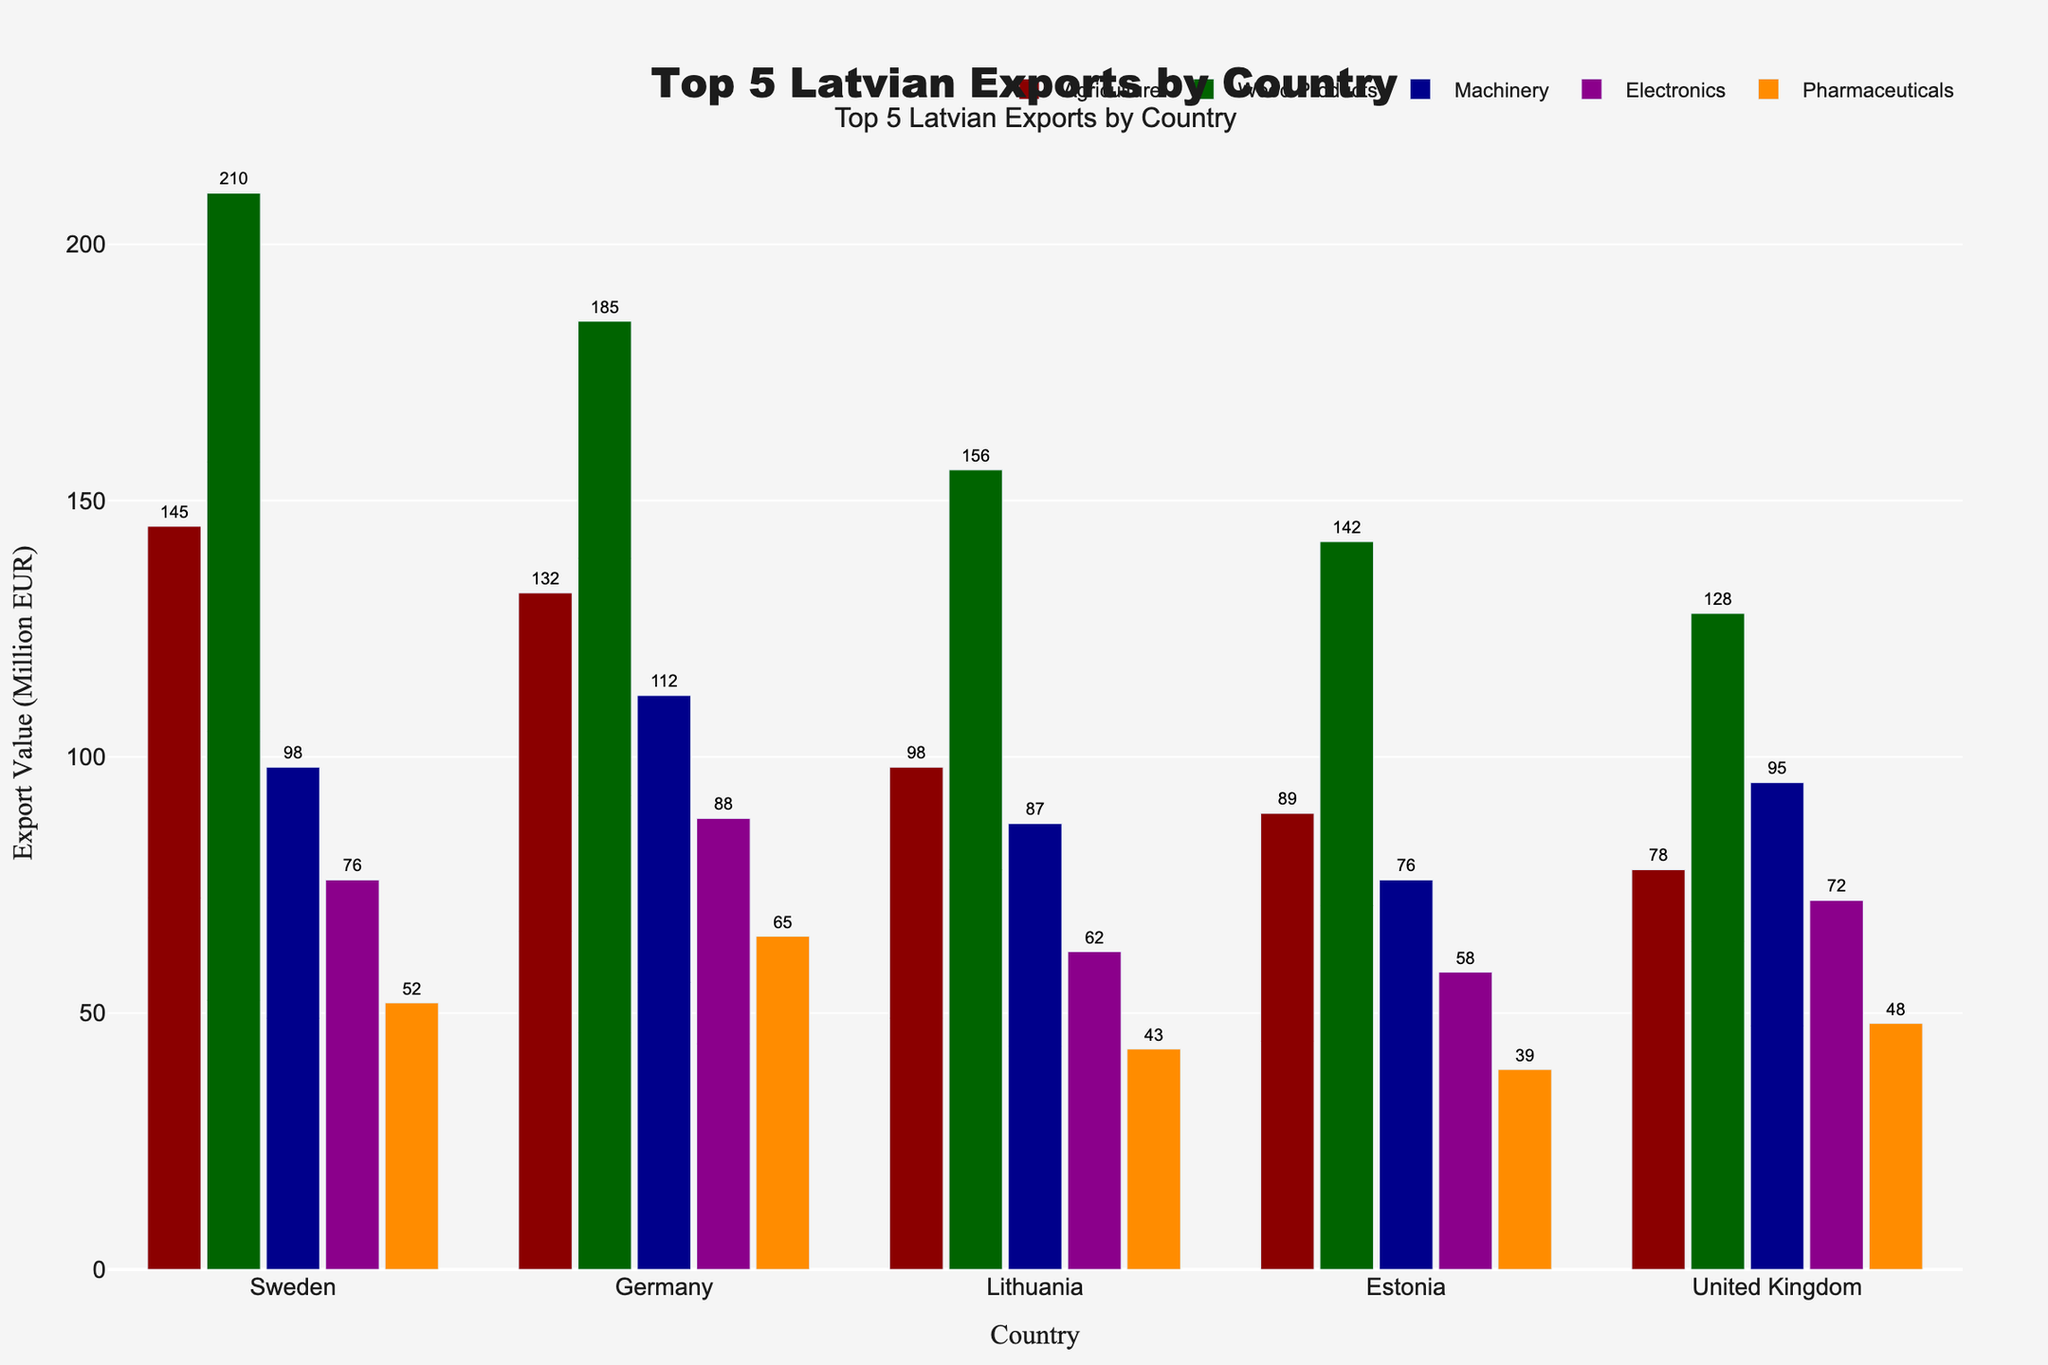What are the top three countries importing Latvian wood products? By examining the heights of the bars for wood products, we see that Sweden, Germany, and Lithuania have the highest values.
Answer: Sweden, Germany, Lithuania Which category accounts for the highest export value to Germany? Compare the bar heights across categories for Germany. The wood products category has the highest bar.
Answer: Wood Products How much more valuable are agriculture exports to Sweden compared to the United Kingdom? Subtract the agriculture export value to the United Kingdom (78) from the value to Sweden (145): 145 - 78.
Answer: 67 Which country receives the most diverse range of export values (widest spread among different categories)? Calculate the range (max - min) for each country and compare them. Germany has the widest range: max (185) - min (65) = 120.
Answer: Germany What is the total export value for electronics across all five countries? Sum the values for electronics: 76 (Sweden) + 88 (Germany) + 62 (Lithuania) + 58 (Estonia) + 72 (United Kingdom).
Answer: 356 In which category does Estonia receive higher export values than Lithuania, and by how much? Compare bars of Estonia and Lithuania across categories, and the wood products category has a higher export value for Estonia (142 - 156 = -14 so this is not applicable). None of the categories fit this condition.
Answer: None Which categories have export values higher than 100 in more than three countries? Look at each category and count the bars taller than 100. Wood Products has values higher than 100 in all five countries.
Answer: Wood Products What's the average export value for pharmaceuticals across all countries? Sum the pharmaceutical values and divide by the number of countries: (52 + 65 + 43 + 39 + 48) / 5 = 49.4.
Answer: 49.4 How does the export value for machinery to the United Kingdom compare to Estonia? Check the bar heights for machinery. United Kingdom: 95, Estonia: 76. Subtract Estonia's value from the United Kingdom's value: 95 - 76.
Answer: 19 